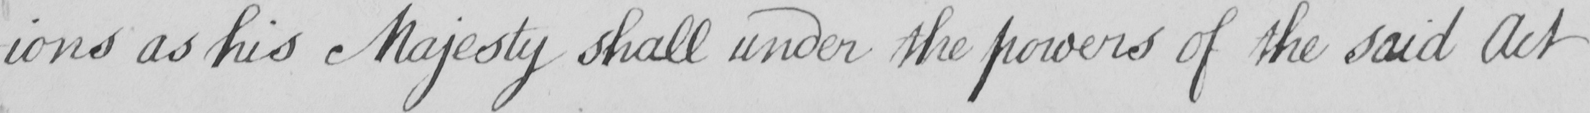What does this handwritten line say? -ions as his Majesty shall under the powers of the said Act 